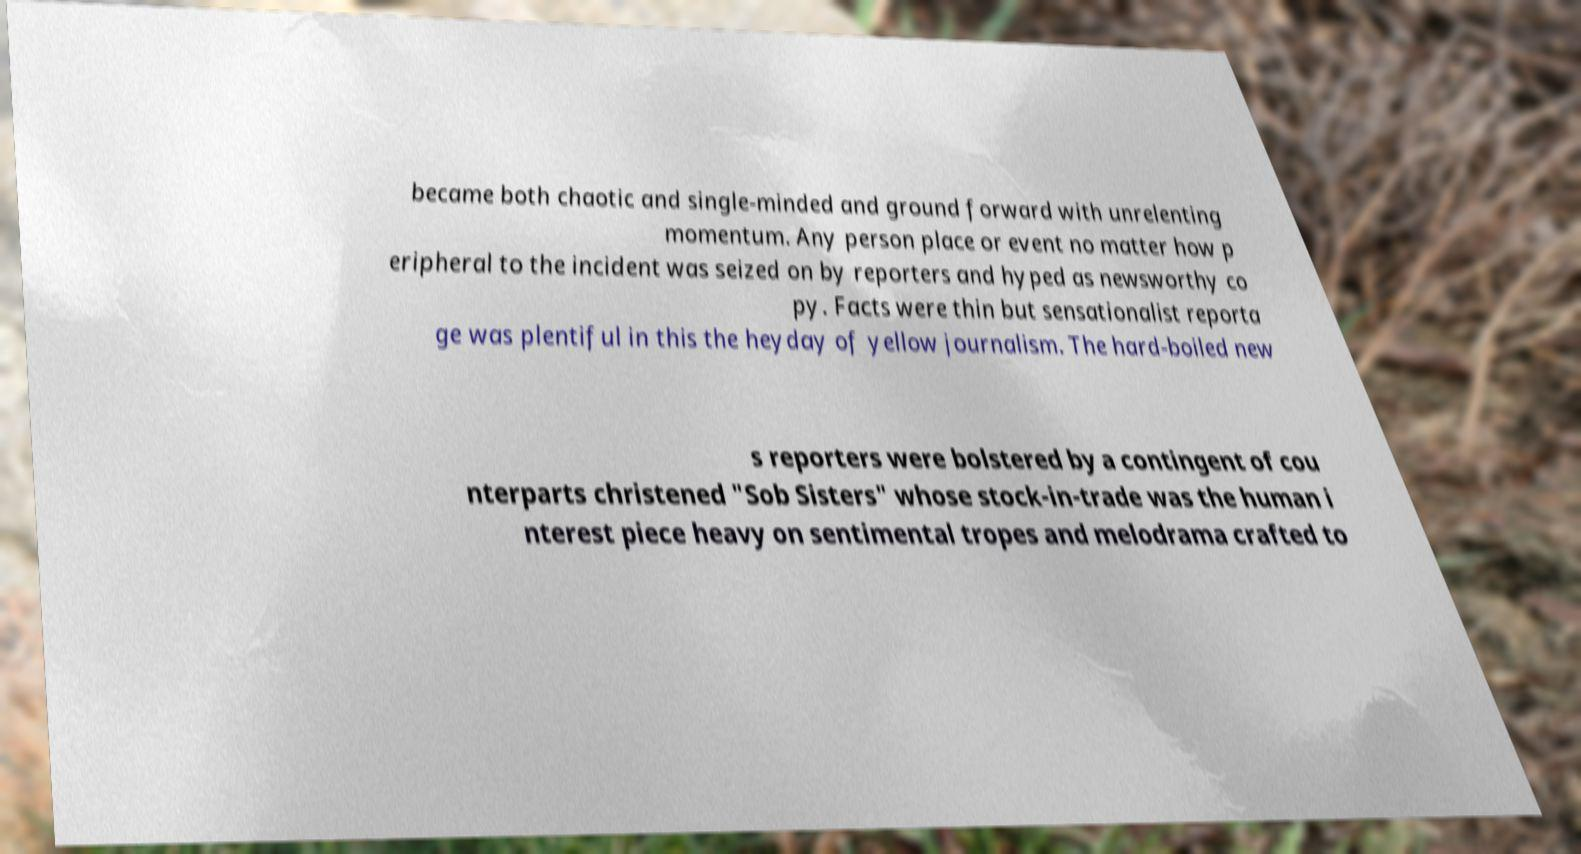Please read and relay the text visible in this image. What does it say? became both chaotic and single-minded and ground forward with unrelenting momentum. Any person place or event no matter how p eripheral to the incident was seized on by reporters and hyped as newsworthy co py. Facts were thin but sensationalist reporta ge was plentiful in this the heyday of yellow journalism. The hard-boiled new s reporters were bolstered by a contingent of cou nterparts christened "Sob Sisters" whose stock-in-trade was the human i nterest piece heavy on sentimental tropes and melodrama crafted to 